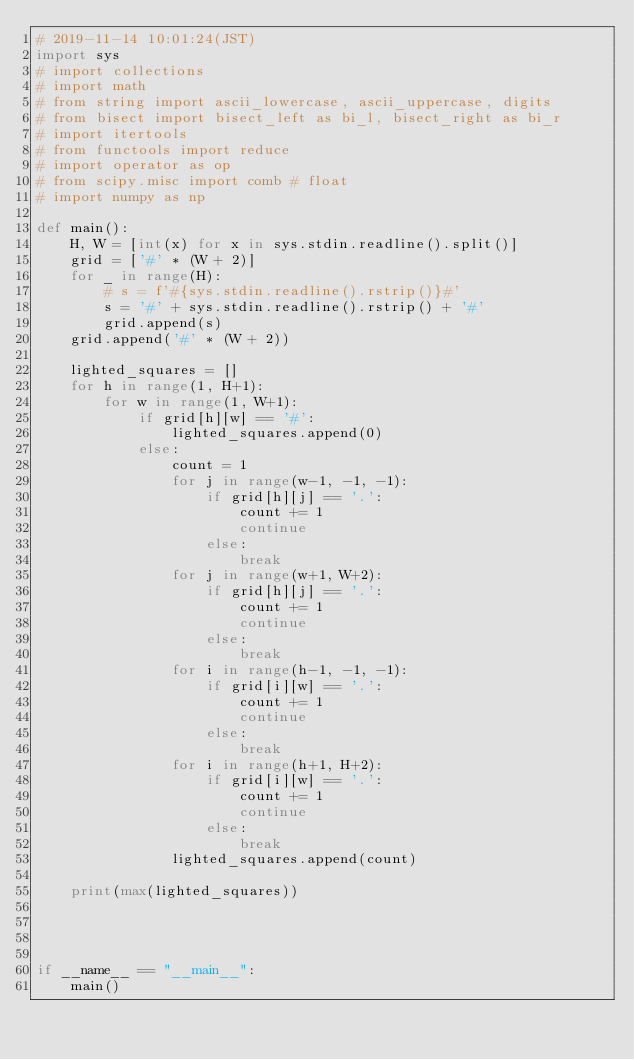Convert code to text. <code><loc_0><loc_0><loc_500><loc_500><_Python_># 2019-11-14 10:01:24(JST)
import sys
# import collections
# import math
# from string import ascii_lowercase, ascii_uppercase, digits
# from bisect import bisect_left as bi_l, bisect_right as bi_r
# import itertools
# from functools import reduce
# import operator as op
# from scipy.misc import comb # float
# import numpy as np 

def main():
    H, W = [int(x) for x in sys.stdin.readline().split()]
    grid = ['#' * (W + 2)]
    for _ in range(H):
        # s = f'#{sys.stdin.readline().rstrip()}#'
        s = '#' + sys.stdin.readline().rstrip() + '#'
        grid.append(s)
    grid.append('#' * (W + 2))

    lighted_squares = []
    for h in range(1, H+1):
        for w in range(1, W+1):
            if grid[h][w] == '#':
                lighted_squares.append(0)
            else:
                count = 1
                for j in range(w-1, -1, -1):
                    if grid[h][j] == '.':
                        count += 1
                        continue
                    else:
                        break
                for j in range(w+1, W+2):
                    if grid[h][j] == '.':
                        count += 1
                        continue
                    else:
                        break
                for i in range(h-1, -1, -1):
                    if grid[i][w] == '.':
                        count += 1
                        continue
                    else:
                        break
                for i in range(h+1, H+2):
                    if grid[i][w] == '.':
                        count += 1
                        continue
                    else:
                        break
                lighted_squares.append(count)
    
    print(max(lighted_squares))




if __name__ == "__main__":
    main()
</code> 